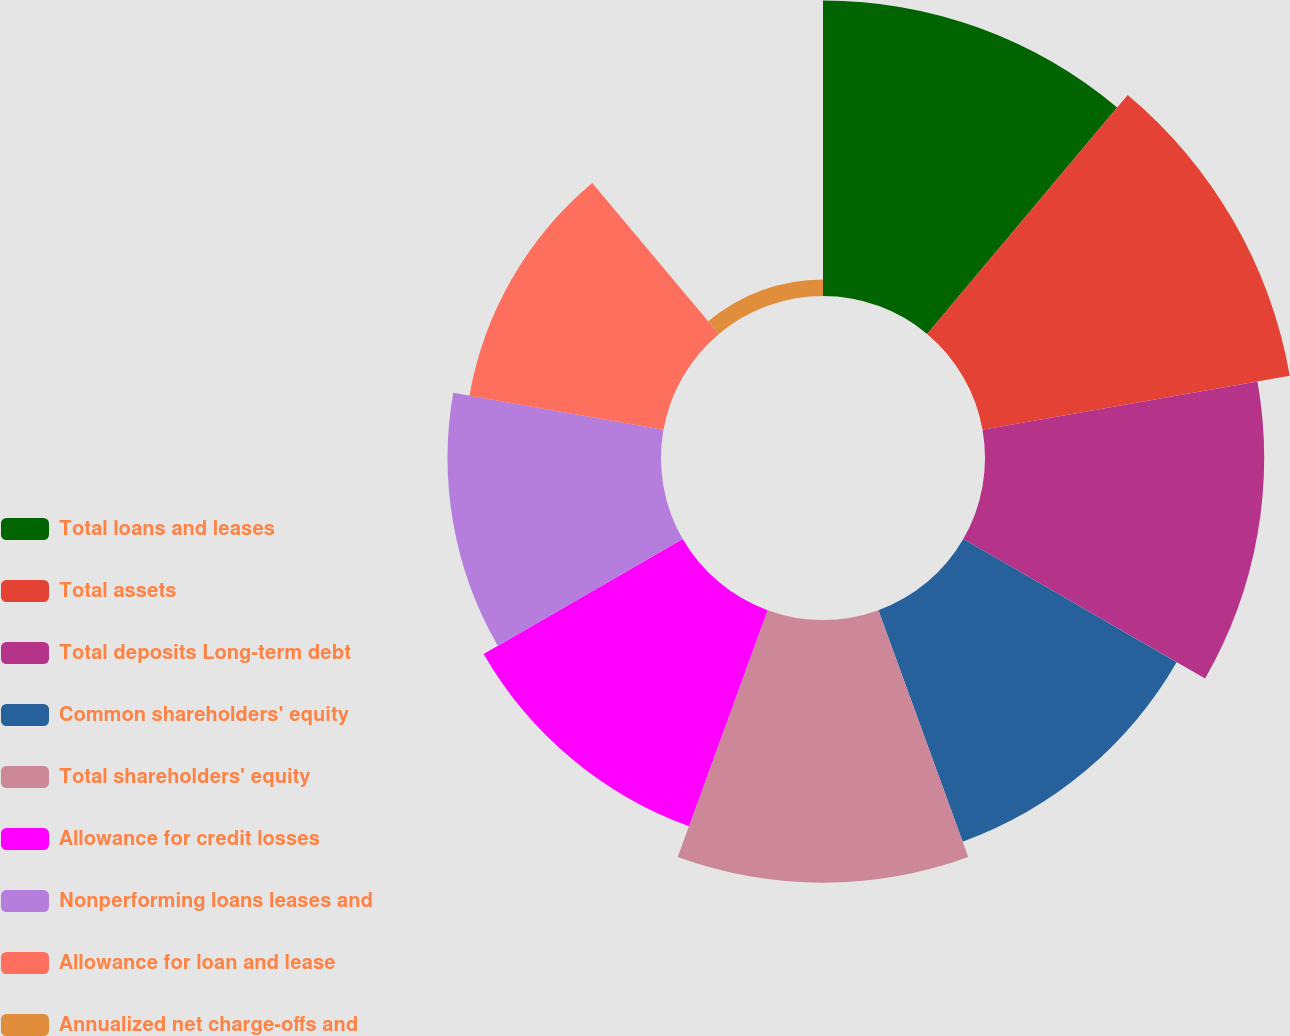<chart> <loc_0><loc_0><loc_500><loc_500><pie_chart><fcel>Total loans and leases<fcel>Total assets<fcel>Total deposits Long-term debt<fcel>Common shareholders' equity<fcel>Total shareholders' equity<fcel>Allowance for credit losses<fcel>Nonperforming loans leases and<fcel>Allowance for loan and lease<fcel>Annualized net charge-offs and<nl><fcel>14.4%<fcel>15.2%<fcel>13.6%<fcel>12.0%<fcel>12.8%<fcel>11.2%<fcel>10.4%<fcel>9.6%<fcel>0.8%<nl></chart> 